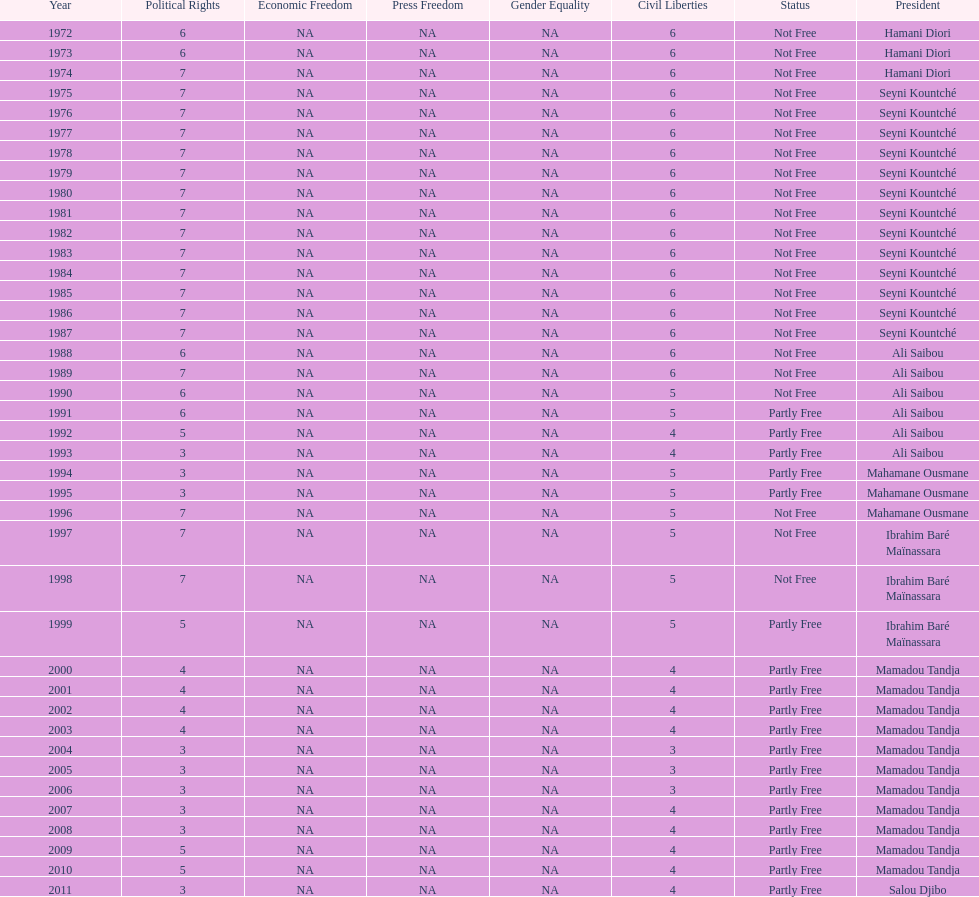How many years was it before the first partly free status? 18. 